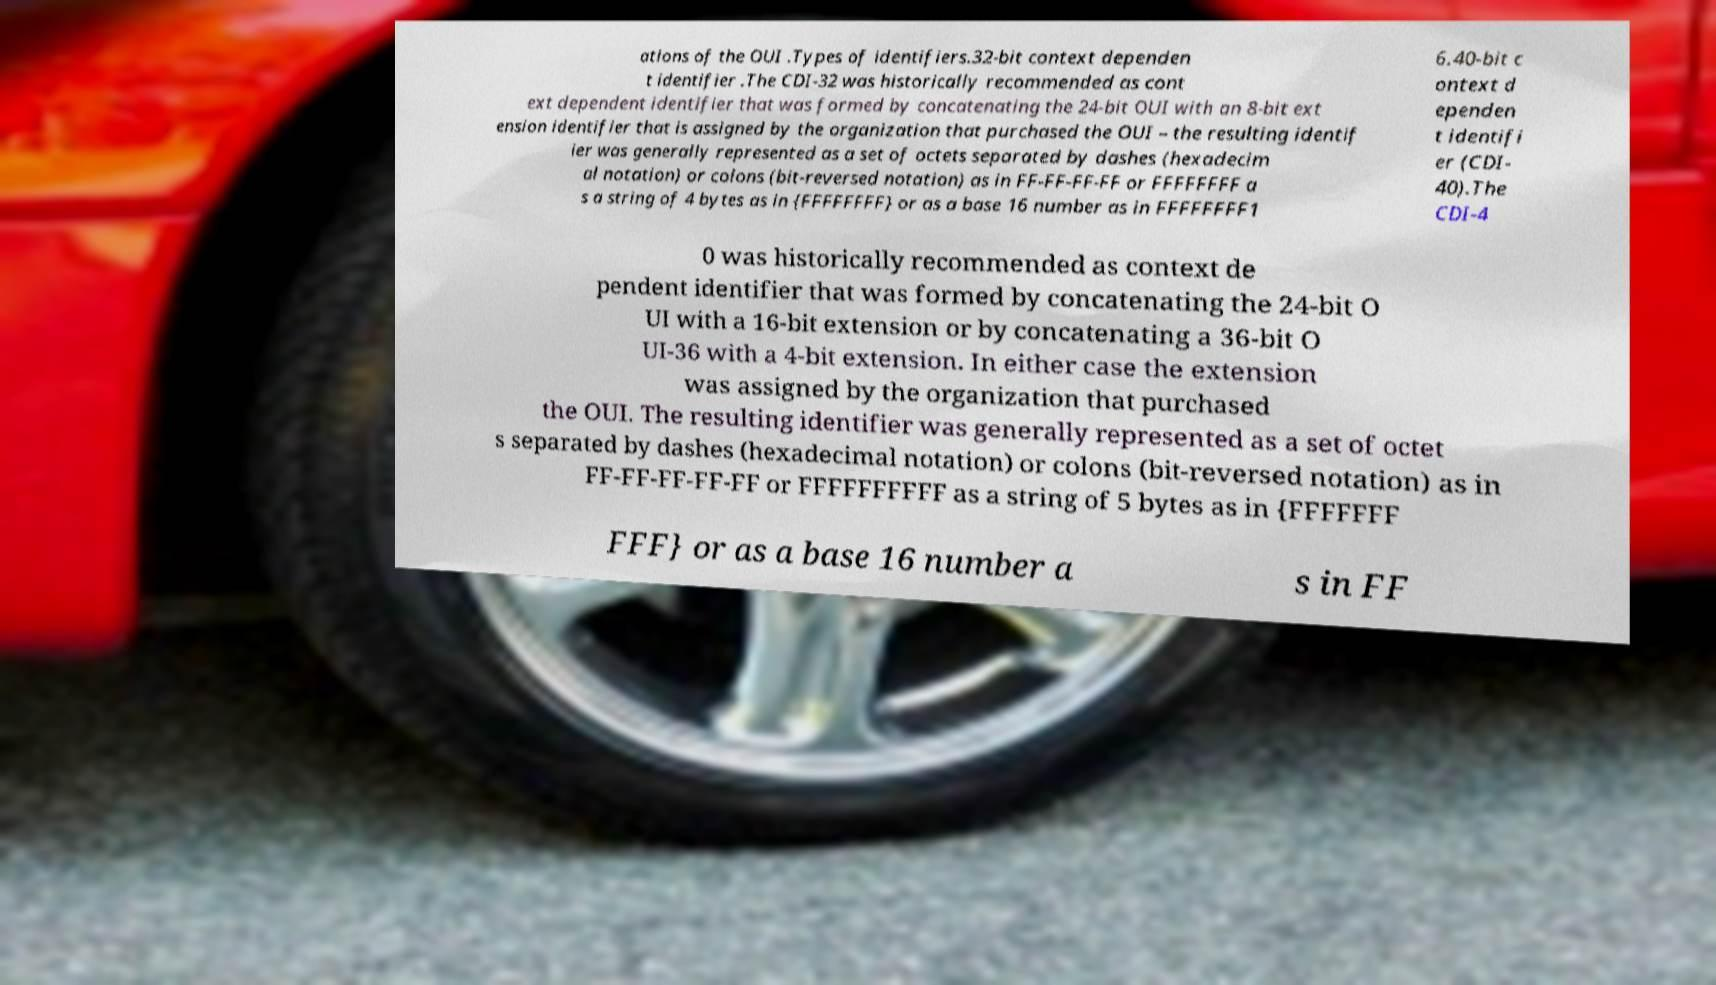Please read and relay the text visible in this image. What does it say? ations of the OUI .Types of identifiers.32-bit context dependen t identifier .The CDI-32 was historically recommended as cont ext dependent identifier that was formed by concatenating the 24-bit OUI with an 8-bit ext ension identifier that is assigned by the organization that purchased the OUI – the resulting identif ier was generally represented as a set of octets separated by dashes (hexadecim al notation) or colons (bit-reversed notation) as in FF-FF-FF-FF or FFFFFFFF a s a string of 4 bytes as in {FFFFFFFF} or as a base 16 number as in FFFFFFFF1 6.40-bit c ontext d ependen t identifi er (CDI- 40).The CDI-4 0 was historically recommended as context de pendent identifier that was formed by concatenating the 24-bit O UI with a 16-bit extension or by concatenating a 36-bit O UI-36 with a 4-bit extension. In either case the extension was assigned by the organization that purchased the OUI. The resulting identifier was generally represented as a set of octet s separated by dashes (hexadecimal notation) or colons (bit-reversed notation) as in FF-FF-FF-FF-FF or FFFFFFFFFF as a string of 5 bytes as in {FFFFFFF FFF} or as a base 16 number a s in FF 